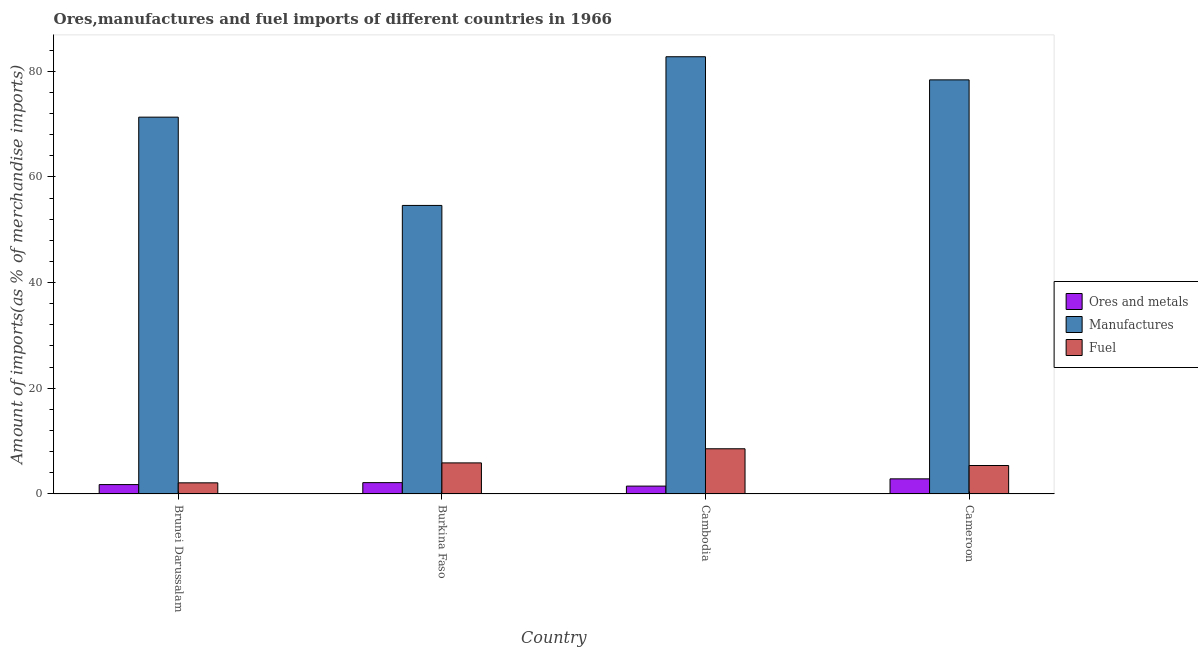Are the number of bars per tick equal to the number of legend labels?
Provide a short and direct response. Yes. What is the label of the 1st group of bars from the left?
Provide a short and direct response. Brunei Darussalam. In how many cases, is the number of bars for a given country not equal to the number of legend labels?
Provide a short and direct response. 0. What is the percentage of ores and metals imports in Brunei Darussalam?
Your response must be concise. 1.78. Across all countries, what is the maximum percentage of fuel imports?
Provide a succinct answer. 8.55. Across all countries, what is the minimum percentage of fuel imports?
Your answer should be compact. 2.11. In which country was the percentage of manufactures imports maximum?
Provide a short and direct response. Cambodia. In which country was the percentage of ores and metals imports minimum?
Make the answer very short. Cambodia. What is the total percentage of manufactures imports in the graph?
Provide a short and direct response. 286.99. What is the difference between the percentage of fuel imports in Burkina Faso and that in Cameroon?
Ensure brevity in your answer.  0.49. What is the difference between the percentage of fuel imports in Cambodia and the percentage of manufactures imports in Burkina Faso?
Provide a short and direct response. -46.05. What is the average percentage of ores and metals imports per country?
Provide a short and direct response. 2.07. What is the difference between the percentage of ores and metals imports and percentage of fuel imports in Cameroon?
Your response must be concise. -2.52. In how many countries, is the percentage of fuel imports greater than 80 %?
Provide a short and direct response. 0. What is the ratio of the percentage of fuel imports in Burkina Faso to that in Cameroon?
Ensure brevity in your answer.  1.09. Is the percentage of ores and metals imports in Cambodia less than that in Cameroon?
Give a very brief answer. Yes. Is the difference between the percentage of ores and metals imports in Brunei Darussalam and Cambodia greater than the difference between the percentage of manufactures imports in Brunei Darussalam and Cambodia?
Make the answer very short. Yes. What is the difference between the highest and the second highest percentage of fuel imports?
Your response must be concise. 2.67. What is the difference between the highest and the lowest percentage of ores and metals imports?
Give a very brief answer. 1.37. In how many countries, is the percentage of fuel imports greater than the average percentage of fuel imports taken over all countries?
Offer a terse response. 2. What does the 2nd bar from the left in Cameroon represents?
Offer a terse response. Manufactures. What does the 2nd bar from the right in Cameroon represents?
Provide a short and direct response. Manufactures. Is it the case that in every country, the sum of the percentage of ores and metals imports and percentage of manufactures imports is greater than the percentage of fuel imports?
Offer a terse response. Yes. How many countries are there in the graph?
Keep it short and to the point. 4. Are the values on the major ticks of Y-axis written in scientific E-notation?
Your answer should be compact. No. Does the graph contain any zero values?
Make the answer very short. No. Does the graph contain grids?
Your answer should be compact. No. How are the legend labels stacked?
Your answer should be very brief. Vertical. What is the title of the graph?
Your answer should be compact. Ores,manufactures and fuel imports of different countries in 1966. What is the label or title of the Y-axis?
Provide a short and direct response. Amount of imports(as % of merchandise imports). What is the Amount of imports(as % of merchandise imports) in Ores and metals in Brunei Darussalam?
Your answer should be very brief. 1.78. What is the Amount of imports(as % of merchandise imports) in Manufactures in Brunei Darussalam?
Provide a succinct answer. 71.3. What is the Amount of imports(as % of merchandise imports) in Fuel in Brunei Darussalam?
Your response must be concise. 2.11. What is the Amount of imports(as % of merchandise imports) of Ores and metals in Burkina Faso?
Make the answer very short. 2.15. What is the Amount of imports(as % of merchandise imports) of Manufactures in Burkina Faso?
Give a very brief answer. 54.6. What is the Amount of imports(as % of merchandise imports) in Fuel in Burkina Faso?
Make the answer very short. 5.88. What is the Amount of imports(as % of merchandise imports) of Ores and metals in Cambodia?
Keep it short and to the point. 1.49. What is the Amount of imports(as % of merchandise imports) of Manufactures in Cambodia?
Give a very brief answer. 82.73. What is the Amount of imports(as % of merchandise imports) in Fuel in Cambodia?
Give a very brief answer. 8.55. What is the Amount of imports(as % of merchandise imports) of Ores and metals in Cameroon?
Your answer should be compact. 2.86. What is the Amount of imports(as % of merchandise imports) in Manufactures in Cameroon?
Offer a very short reply. 78.36. What is the Amount of imports(as % of merchandise imports) of Fuel in Cameroon?
Your response must be concise. 5.39. Across all countries, what is the maximum Amount of imports(as % of merchandise imports) in Ores and metals?
Provide a short and direct response. 2.86. Across all countries, what is the maximum Amount of imports(as % of merchandise imports) in Manufactures?
Give a very brief answer. 82.73. Across all countries, what is the maximum Amount of imports(as % of merchandise imports) in Fuel?
Provide a short and direct response. 8.55. Across all countries, what is the minimum Amount of imports(as % of merchandise imports) in Ores and metals?
Offer a terse response. 1.49. Across all countries, what is the minimum Amount of imports(as % of merchandise imports) of Manufactures?
Give a very brief answer. 54.6. Across all countries, what is the minimum Amount of imports(as % of merchandise imports) of Fuel?
Keep it short and to the point. 2.11. What is the total Amount of imports(as % of merchandise imports) in Ores and metals in the graph?
Ensure brevity in your answer.  8.27. What is the total Amount of imports(as % of merchandise imports) of Manufactures in the graph?
Provide a short and direct response. 286.99. What is the total Amount of imports(as % of merchandise imports) in Fuel in the graph?
Your answer should be very brief. 21.92. What is the difference between the Amount of imports(as % of merchandise imports) in Ores and metals in Brunei Darussalam and that in Burkina Faso?
Your response must be concise. -0.37. What is the difference between the Amount of imports(as % of merchandise imports) of Manufactures in Brunei Darussalam and that in Burkina Faso?
Offer a very short reply. 16.71. What is the difference between the Amount of imports(as % of merchandise imports) of Fuel in Brunei Darussalam and that in Burkina Faso?
Keep it short and to the point. -3.77. What is the difference between the Amount of imports(as % of merchandise imports) of Ores and metals in Brunei Darussalam and that in Cambodia?
Offer a terse response. 0.29. What is the difference between the Amount of imports(as % of merchandise imports) of Manufactures in Brunei Darussalam and that in Cambodia?
Offer a terse response. -11.43. What is the difference between the Amount of imports(as % of merchandise imports) in Fuel in Brunei Darussalam and that in Cambodia?
Keep it short and to the point. -6.44. What is the difference between the Amount of imports(as % of merchandise imports) in Ores and metals in Brunei Darussalam and that in Cameroon?
Give a very brief answer. -1.09. What is the difference between the Amount of imports(as % of merchandise imports) in Manufactures in Brunei Darussalam and that in Cameroon?
Your answer should be very brief. -7.05. What is the difference between the Amount of imports(as % of merchandise imports) of Fuel in Brunei Darussalam and that in Cameroon?
Offer a terse response. -3.28. What is the difference between the Amount of imports(as % of merchandise imports) of Ores and metals in Burkina Faso and that in Cambodia?
Make the answer very short. 0.66. What is the difference between the Amount of imports(as % of merchandise imports) in Manufactures in Burkina Faso and that in Cambodia?
Provide a short and direct response. -28.14. What is the difference between the Amount of imports(as % of merchandise imports) in Fuel in Burkina Faso and that in Cambodia?
Offer a terse response. -2.67. What is the difference between the Amount of imports(as % of merchandise imports) of Ores and metals in Burkina Faso and that in Cameroon?
Offer a very short reply. -0.71. What is the difference between the Amount of imports(as % of merchandise imports) of Manufactures in Burkina Faso and that in Cameroon?
Give a very brief answer. -23.76. What is the difference between the Amount of imports(as % of merchandise imports) in Fuel in Burkina Faso and that in Cameroon?
Give a very brief answer. 0.49. What is the difference between the Amount of imports(as % of merchandise imports) of Ores and metals in Cambodia and that in Cameroon?
Your answer should be very brief. -1.37. What is the difference between the Amount of imports(as % of merchandise imports) of Manufactures in Cambodia and that in Cameroon?
Offer a very short reply. 4.38. What is the difference between the Amount of imports(as % of merchandise imports) of Fuel in Cambodia and that in Cameroon?
Give a very brief answer. 3.17. What is the difference between the Amount of imports(as % of merchandise imports) in Ores and metals in Brunei Darussalam and the Amount of imports(as % of merchandise imports) in Manufactures in Burkina Faso?
Your answer should be very brief. -52.82. What is the difference between the Amount of imports(as % of merchandise imports) of Ores and metals in Brunei Darussalam and the Amount of imports(as % of merchandise imports) of Fuel in Burkina Faso?
Keep it short and to the point. -4.1. What is the difference between the Amount of imports(as % of merchandise imports) of Manufactures in Brunei Darussalam and the Amount of imports(as % of merchandise imports) of Fuel in Burkina Faso?
Ensure brevity in your answer.  65.42. What is the difference between the Amount of imports(as % of merchandise imports) in Ores and metals in Brunei Darussalam and the Amount of imports(as % of merchandise imports) in Manufactures in Cambodia?
Provide a short and direct response. -80.96. What is the difference between the Amount of imports(as % of merchandise imports) in Ores and metals in Brunei Darussalam and the Amount of imports(as % of merchandise imports) in Fuel in Cambodia?
Your answer should be compact. -6.78. What is the difference between the Amount of imports(as % of merchandise imports) in Manufactures in Brunei Darussalam and the Amount of imports(as % of merchandise imports) in Fuel in Cambodia?
Offer a terse response. 62.75. What is the difference between the Amount of imports(as % of merchandise imports) of Ores and metals in Brunei Darussalam and the Amount of imports(as % of merchandise imports) of Manufactures in Cameroon?
Your answer should be very brief. -76.58. What is the difference between the Amount of imports(as % of merchandise imports) in Ores and metals in Brunei Darussalam and the Amount of imports(as % of merchandise imports) in Fuel in Cameroon?
Offer a terse response. -3.61. What is the difference between the Amount of imports(as % of merchandise imports) of Manufactures in Brunei Darussalam and the Amount of imports(as % of merchandise imports) of Fuel in Cameroon?
Keep it short and to the point. 65.92. What is the difference between the Amount of imports(as % of merchandise imports) of Ores and metals in Burkina Faso and the Amount of imports(as % of merchandise imports) of Manufactures in Cambodia?
Your answer should be compact. -80.59. What is the difference between the Amount of imports(as % of merchandise imports) in Ores and metals in Burkina Faso and the Amount of imports(as % of merchandise imports) in Fuel in Cambodia?
Keep it short and to the point. -6.41. What is the difference between the Amount of imports(as % of merchandise imports) of Manufactures in Burkina Faso and the Amount of imports(as % of merchandise imports) of Fuel in Cambodia?
Give a very brief answer. 46.05. What is the difference between the Amount of imports(as % of merchandise imports) of Ores and metals in Burkina Faso and the Amount of imports(as % of merchandise imports) of Manufactures in Cameroon?
Your response must be concise. -76.21. What is the difference between the Amount of imports(as % of merchandise imports) in Ores and metals in Burkina Faso and the Amount of imports(as % of merchandise imports) in Fuel in Cameroon?
Offer a terse response. -3.24. What is the difference between the Amount of imports(as % of merchandise imports) of Manufactures in Burkina Faso and the Amount of imports(as % of merchandise imports) of Fuel in Cameroon?
Your response must be concise. 49.21. What is the difference between the Amount of imports(as % of merchandise imports) in Ores and metals in Cambodia and the Amount of imports(as % of merchandise imports) in Manufactures in Cameroon?
Give a very brief answer. -76.87. What is the difference between the Amount of imports(as % of merchandise imports) of Ores and metals in Cambodia and the Amount of imports(as % of merchandise imports) of Fuel in Cameroon?
Provide a short and direct response. -3.9. What is the difference between the Amount of imports(as % of merchandise imports) in Manufactures in Cambodia and the Amount of imports(as % of merchandise imports) in Fuel in Cameroon?
Provide a succinct answer. 77.35. What is the average Amount of imports(as % of merchandise imports) in Ores and metals per country?
Provide a short and direct response. 2.07. What is the average Amount of imports(as % of merchandise imports) in Manufactures per country?
Provide a short and direct response. 71.75. What is the average Amount of imports(as % of merchandise imports) in Fuel per country?
Provide a short and direct response. 5.48. What is the difference between the Amount of imports(as % of merchandise imports) of Ores and metals and Amount of imports(as % of merchandise imports) of Manufactures in Brunei Darussalam?
Make the answer very short. -69.53. What is the difference between the Amount of imports(as % of merchandise imports) in Ores and metals and Amount of imports(as % of merchandise imports) in Fuel in Brunei Darussalam?
Make the answer very short. -0.33. What is the difference between the Amount of imports(as % of merchandise imports) in Manufactures and Amount of imports(as % of merchandise imports) in Fuel in Brunei Darussalam?
Provide a succinct answer. 69.2. What is the difference between the Amount of imports(as % of merchandise imports) of Ores and metals and Amount of imports(as % of merchandise imports) of Manufactures in Burkina Faso?
Make the answer very short. -52.45. What is the difference between the Amount of imports(as % of merchandise imports) in Ores and metals and Amount of imports(as % of merchandise imports) in Fuel in Burkina Faso?
Your response must be concise. -3.73. What is the difference between the Amount of imports(as % of merchandise imports) in Manufactures and Amount of imports(as % of merchandise imports) in Fuel in Burkina Faso?
Provide a short and direct response. 48.72. What is the difference between the Amount of imports(as % of merchandise imports) of Ores and metals and Amount of imports(as % of merchandise imports) of Manufactures in Cambodia?
Your answer should be compact. -81.25. What is the difference between the Amount of imports(as % of merchandise imports) in Ores and metals and Amount of imports(as % of merchandise imports) in Fuel in Cambodia?
Provide a succinct answer. -7.06. What is the difference between the Amount of imports(as % of merchandise imports) in Manufactures and Amount of imports(as % of merchandise imports) in Fuel in Cambodia?
Keep it short and to the point. 74.18. What is the difference between the Amount of imports(as % of merchandise imports) in Ores and metals and Amount of imports(as % of merchandise imports) in Manufactures in Cameroon?
Your response must be concise. -75.5. What is the difference between the Amount of imports(as % of merchandise imports) in Ores and metals and Amount of imports(as % of merchandise imports) in Fuel in Cameroon?
Your answer should be very brief. -2.52. What is the difference between the Amount of imports(as % of merchandise imports) of Manufactures and Amount of imports(as % of merchandise imports) of Fuel in Cameroon?
Ensure brevity in your answer.  72.97. What is the ratio of the Amount of imports(as % of merchandise imports) of Ores and metals in Brunei Darussalam to that in Burkina Faso?
Keep it short and to the point. 0.83. What is the ratio of the Amount of imports(as % of merchandise imports) of Manufactures in Brunei Darussalam to that in Burkina Faso?
Offer a terse response. 1.31. What is the ratio of the Amount of imports(as % of merchandise imports) in Fuel in Brunei Darussalam to that in Burkina Faso?
Offer a very short reply. 0.36. What is the ratio of the Amount of imports(as % of merchandise imports) of Ores and metals in Brunei Darussalam to that in Cambodia?
Your response must be concise. 1.19. What is the ratio of the Amount of imports(as % of merchandise imports) in Manufactures in Brunei Darussalam to that in Cambodia?
Your answer should be compact. 0.86. What is the ratio of the Amount of imports(as % of merchandise imports) of Fuel in Brunei Darussalam to that in Cambodia?
Offer a terse response. 0.25. What is the ratio of the Amount of imports(as % of merchandise imports) in Ores and metals in Brunei Darussalam to that in Cameroon?
Make the answer very short. 0.62. What is the ratio of the Amount of imports(as % of merchandise imports) in Manufactures in Brunei Darussalam to that in Cameroon?
Your answer should be compact. 0.91. What is the ratio of the Amount of imports(as % of merchandise imports) of Fuel in Brunei Darussalam to that in Cameroon?
Provide a succinct answer. 0.39. What is the ratio of the Amount of imports(as % of merchandise imports) of Ores and metals in Burkina Faso to that in Cambodia?
Make the answer very short. 1.44. What is the ratio of the Amount of imports(as % of merchandise imports) of Manufactures in Burkina Faso to that in Cambodia?
Provide a succinct answer. 0.66. What is the ratio of the Amount of imports(as % of merchandise imports) in Fuel in Burkina Faso to that in Cambodia?
Your answer should be compact. 0.69. What is the ratio of the Amount of imports(as % of merchandise imports) of Ores and metals in Burkina Faso to that in Cameroon?
Your response must be concise. 0.75. What is the ratio of the Amount of imports(as % of merchandise imports) of Manufactures in Burkina Faso to that in Cameroon?
Make the answer very short. 0.7. What is the ratio of the Amount of imports(as % of merchandise imports) of Fuel in Burkina Faso to that in Cameroon?
Make the answer very short. 1.09. What is the ratio of the Amount of imports(as % of merchandise imports) in Ores and metals in Cambodia to that in Cameroon?
Make the answer very short. 0.52. What is the ratio of the Amount of imports(as % of merchandise imports) in Manufactures in Cambodia to that in Cameroon?
Your answer should be very brief. 1.06. What is the ratio of the Amount of imports(as % of merchandise imports) of Fuel in Cambodia to that in Cameroon?
Offer a terse response. 1.59. What is the difference between the highest and the second highest Amount of imports(as % of merchandise imports) in Ores and metals?
Provide a succinct answer. 0.71. What is the difference between the highest and the second highest Amount of imports(as % of merchandise imports) in Manufactures?
Your answer should be compact. 4.38. What is the difference between the highest and the second highest Amount of imports(as % of merchandise imports) of Fuel?
Provide a short and direct response. 2.67. What is the difference between the highest and the lowest Amount of imports(as % of merchandise imports) in Ores and metals?
Your response must be concise. 1.37. What is the difference between the highest and the lowest Amount of imports(as % of merchandise imports) of Manufactures?
Your answer should be very brief. 28.14. What is the difference between the highest and the lowest Amount of imports(as % of merchandise imports) in Fuel?
Offer a very short reply. 6.44. 